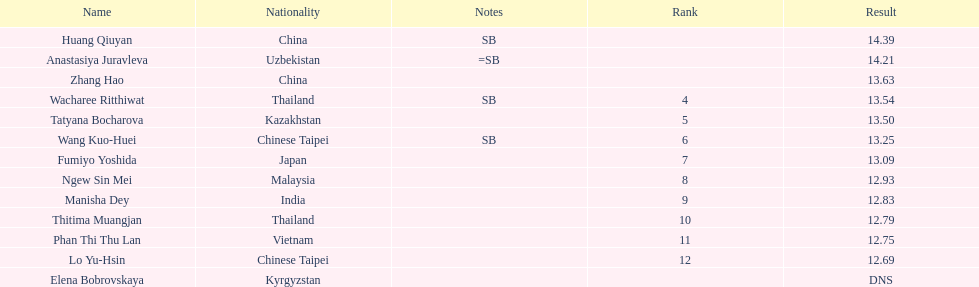How many athletes were from china? 2. Could you parse the entire table as a dict? {'header': ['Name', 'Nationality', 'Notes', 'Rank', 'Result'], 'rows': [['Huang Qiuyan', 'China', 'SB', '', '14.39'], ['Anastasiya Juravleva', 'Uzbekistan', '=SB', '', '14.21'], ['Zhang Hao', 'China', '', '', '13.63'], ['Wacharee Ritthiwat', 'Thailand', 'SB', '4', '13.54'], ['Tatyana Bocharova', 'Kazakhstan', '', '5', '13.50'], ['Wang Kuo-Huei', 'Chinese Taipei', 'SB', '6', '13.25'], ['Fumiyo Yoshida', 'Japan', '', '7', '13.09'], ['Ngew Sin Mei', 'Malaysia', '', '8', '12.93'], ['Manisha Dey', 'India', '', '9', '12.83'], ['Thitima Muangjan', 'Thailand', '', '10', '12.79'], ['Phan Thi Thu Lan', 'Vietnam', '', '11', '12.75'], ['Lo Yu-Hsin', 'Chinese Taipei', '', '12', '12.69'], ['Elena Bobrovskaya', 'Kyrgyzstan', '', '', 'DNS']]} 